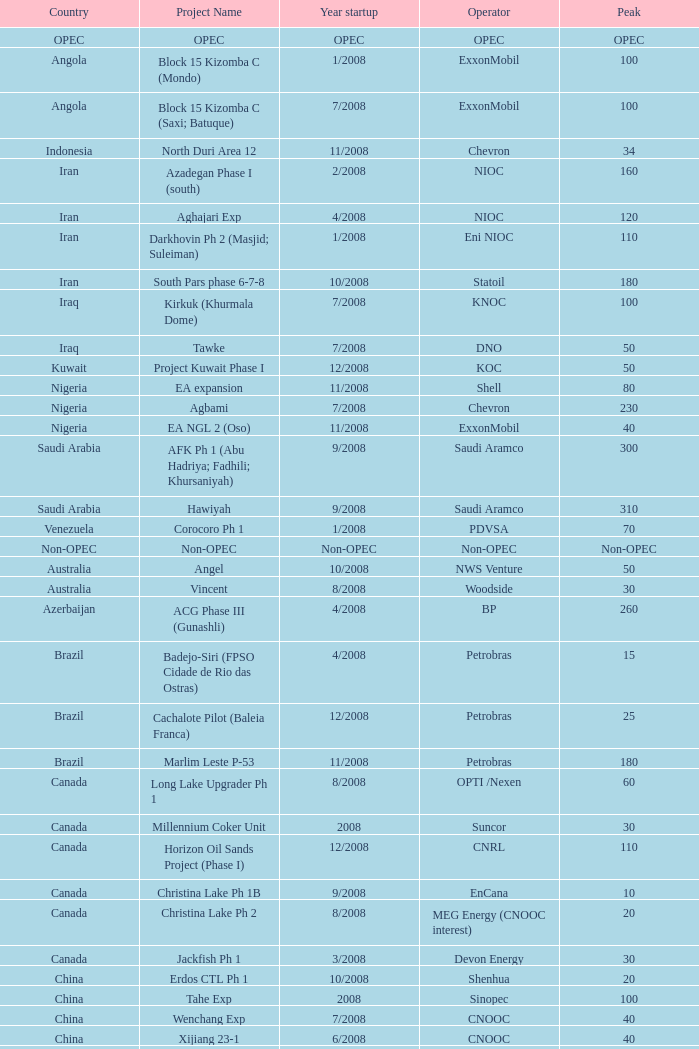What is the project title associated with an opec nation? OPEC. 